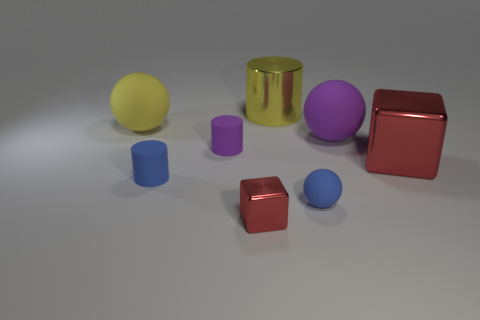Does the metal thing in front of the big red metal thing have the same color as the big matte thing that is left of the tiny purple thing?
Provide a short and direct response. No. There is a purple thing that is the same size as the yellow shiny object; what is its material?
Your response must be concise. Rubber. What is the shape of the blue matte thing that is right of the matte cylinder that is behind the tiny cylinder left of the tiny purple thing?
Offer a terse response. Sphere. The red thing that is the same size as the blue sphere is what shape?
Your answer should be compact. Cube. There is a red shiny cube that is in front of the cube that is right of the tiny red object; how many red shiny cubes are behind it?
Keep it short and to the point. 1. Is the number of tiny purple rubber cylinders behind the big yellow rubber thing greater than the number of big yellow matte objects on the right side of the big red cube?
Keep it short and to the point. No. What number of large rubber things have the same shape as the small metallic thing?
Offer a terse response. 0. How many things are either matte things that are right of the tiny purple cylinder or objects on the right side of the metallic cylinder?
Give a very brief answer. 3. What material is the red thing left of the large metal thing in front of the big yellow thing that is on the left side of the tiny purple rubber cylinder?
Ensure brevity in your answer.  Metal. Do the large sphere to the left of the tiny blue ball and the tiny metal block have the same color?
Provide a short and direct response. No. 